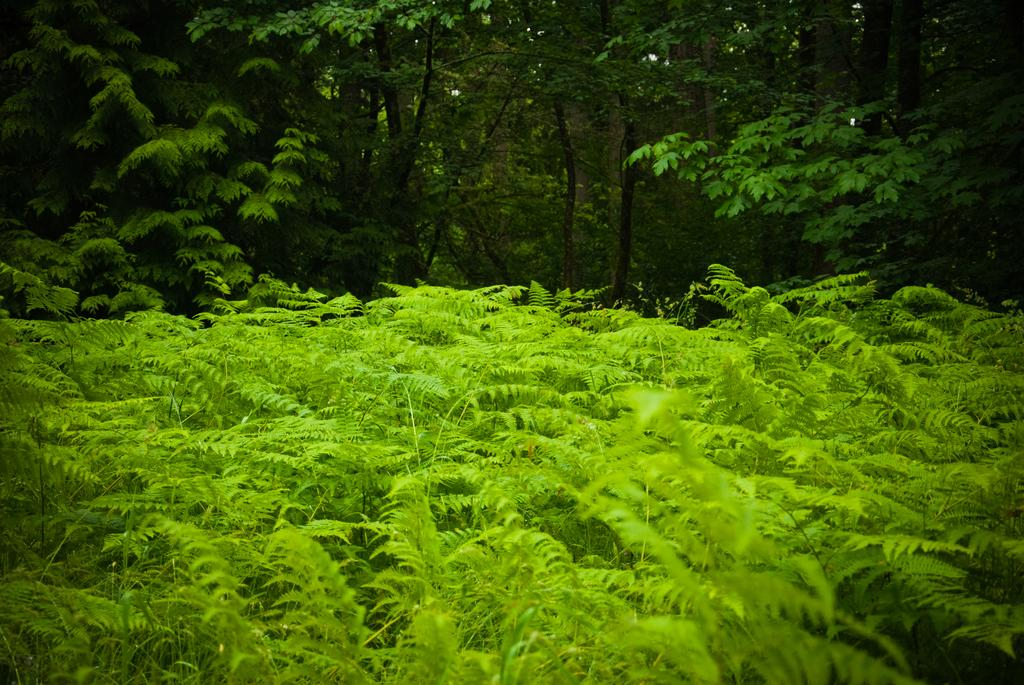What type of vegetation can be seen in the image? There are trees in the image. What is the color of the trees in the foreground? The trees in the foreground are green in color. How do the trees in the background differ from those in the foreground? The trees in the background have both green and brown colors. What type of hospital can be seen in the image? There is no hospital present in the image; it features trees in various colors. How many spiders are visible on the trees in the image? There are no spiders visible on the trees in the image. 